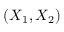Convert formula to latex. <formula><loc_0><loc_0><loc_500><loc_500>( X _ { 1 } , X _ { 2 } )</formula> 